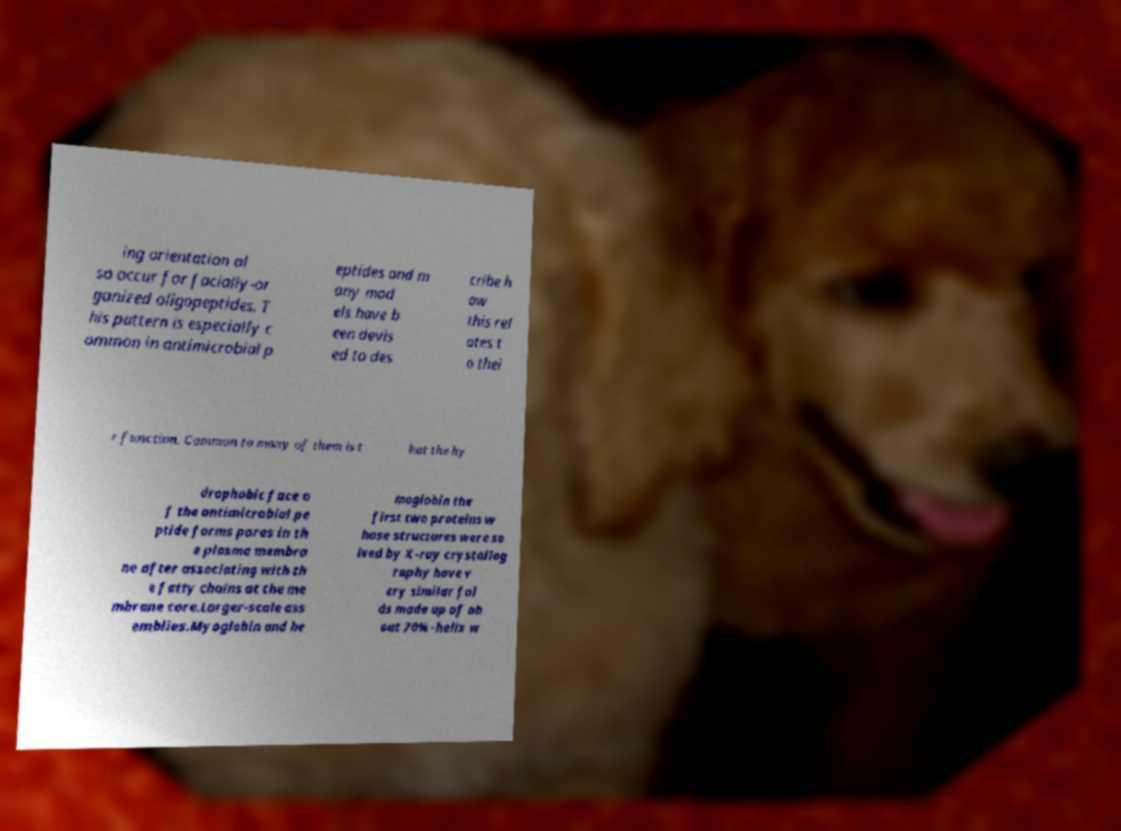Could you extract and type out the text from this image? ing orientation al so occur for facially-or ganized oligopeptides. T his pattern is especially c ommon in antimicrobial p eptides and m any mod els have b een devis ed to des cribe h ow this rel ates t o thei r function. Common to many of them is t hat the hy drophobic face o f the antimicrobial pe ptide forms pores in th e plasma membra ne after associating with th e fatty chains at the me mbrane core.Larger-scale ass emblies.Myoglobin and he moglobin the first two proteins w hose structures were so lved by X-ray crystallog raphy have v ery similar fol ds made up of ab out 70% -helix w 